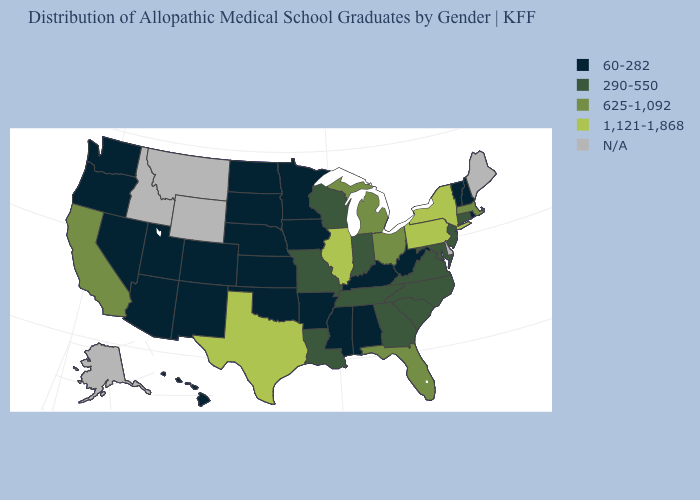Name the states that have a value in the range 60-282?
Short answer required. Alabama, Arizona, Arkansas, Colorado, Hawaii, Iowa, Kansas, Kentucky, Minnesota, Mississippi, Nebraska, Nevada, New Hampshire, New Mexico, North Dakota, Oklahoma, Oregon, Rhode Island, South Dakota, Utah, Vermont, Washington, West Virginia. What is the highest value in the MidWest ?
Answer briefly. 1,121-1,868. What is the value of Iowa?
Write a very short answer. 60-282. Among the states that border Oregon , which have the lowest value?
Keep it brief. Nevada, Washington. What is the value of Connecticut?
Keep it brief. 290-550. Among the states that border Maryland , which have the highest value?
Quick response, please. Pennsylvania. Which states hav the highest value in the Northeast?
Quick response, please. New York, Pennsylvania. Which states have the highest value in the USA?
Write a very short answer. Illinois, New York, Pennsylvania, Texas. Name the states that have a value in the range 60-282?
Be succinct. Alabama, Arizona, Arkansas, Colorado, Hawaii, Iowa, Kansas, Kentucky, Minnesota, Mississippi, Nebraska, Nevada, New Hampshire, New Mexico, North Dakota, Oklahoma, Oregon, Rhode Island, South Dakota, Utah, Vermont, Washington, West Virginia. What is the value of Oklahoma?
Give a very brief answer. 60-282. Does Hawaii have the lowest value in the USA?
Give a very brief answer. Yes. Among the states that border Oklahoma , which have the highest value?
Short answer required. Texas. What is the value of Wisconsin?
Answer briefly. 290-550. What is the value of Montana?
Answer briefly. N/A. 